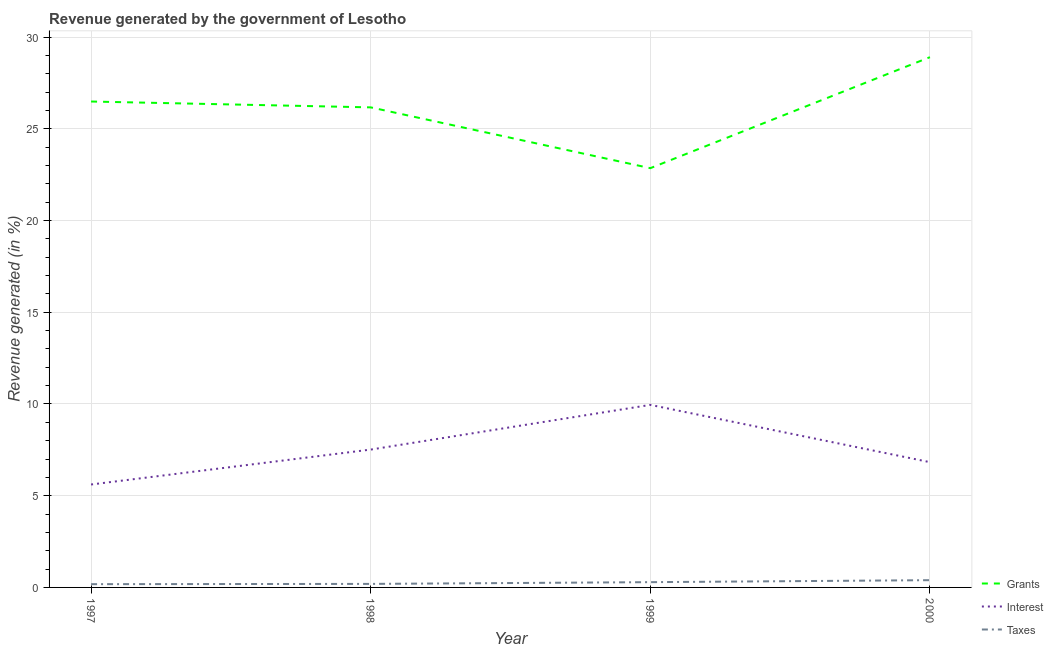How many different coloured lines are there?
Keep it short and to the point. 3. What is the percentage of revenue generated by grants in 1998?
Offer a terse response. 26.17. Across all years, what is the maximum percentage of revenue generated by taxes?
Offer a terse response. 0.4. Across all years, what is the minimum percentage of revenue generated by interest?
Offer a terse response. 5.61. What is the total percentage of revenue generated by taxes in the graph?
Offer a very short reply. 1.05. What is the difference between the percentage of revenue generated by taxes in 1999 and that in 2000?
Your response must be concise. -0.11. What is the difference between the percentage of revenue generated by grants in 1999 and the percentage of revenue generated by taxes in 1998?
Provide a short and direct response. 22.66. What is the average percentage of revenue generated by grants per year?
Keep it short and to the point. 26.1. In the year 2000, what is the difference between the percentage of revenue generated by interest and percentage of revenue generated by taxes?
Make the answer very short. 6.43. In how many years, is the percentage of revenue generated by taxes greater than 2 %?
Your answer should be very brief. 0. What is the ratio of the percentage of revenue generated by grants in 1998 to that in 1999?
Ensure brevity in your answer.  1.15. Is the difference between the percentage of revenue generated by taxes in 1999 and 2000 greater than the difference between the percentage of revenue generated by grants in 1999 and 2000?
Give a very brief answer. Yes. What is the difference between the highest and the second highest percentage of revenue generated by taxes?
Offer a very short reply. 0.11. What is the difference between the highest and the lowest percentage of revenue generated by taxes?
Give a very brief answer. 0.22. Is the percentage of revenue generated by taxes strictly greater than the percentage of revenue generated by interest over the years?
Your answer should be compact. No. How many lines are there?
Your answer should be compact. 3. Are the values on the major ticks of Y-axis written in scientific E-notation?
Your answer should be very brief. No. Does the graph contain any zero values?
Your response must be concise. No. Where does the legend appear in the graph?
Your response must be concise. Bottom right. How many legend labels are there?
Ensure brevity in your answer.  3. How are the legend labels stacked?
Offer a terse response. Vertical. What is the title of the graph?
Offer a terse response. Revenue generated by the government of Lesotho. What is the label or title of the X-axis?
Keep it short and to the point. Year. What is the label or title of the Y-axis?
Make the answer very short. Revenue generated (in %). What is the Revenue generated (in %) in Grants in 1997?
Give a very brief answer. 26.49. What is the Revenue generated (in %) of Interest in 1997?
Make the answer very short. 5.61. What is the Revenue generated (in %) of Taxes in 1997?
Provide a short and direct response. 0.18. What is the Revenue generated (in %) in Grants in 1998?
Offer a terse response. 26.17. What is the Revenue generated (in %) in Interest in 1998?
Your response must be concise. 7.51. What is the Revenue generated (in %) in Taxes in 1998?
Your answer should be compact. 0.19. What is the Revenue generated (in %) in Grants in 1999?
Your response must be concise. 22.86. What is the Revenue generated (in %) in Interest in 1999?
Provide a short and direct response. 9.95. What is the Revenue generated (in %) of Taxes in 1999?
Give a very brief answer. 0.29. What is the Revenue generated (in %) of Grants in 2000?
Give a very brief answer. 28.91. What is the Revenue generated (in %) in Interest in 2000?
Ensure brevity in your answer.  6.83. What is the Revenue generated (in %) of Taxes in 2000?
Give a very brief answer. 0.4. Across all years, what is the maximum Revenue generated (in %) of Grants?
Your response must be concise. 28.91. Across all years, what is the maximum Revenue generated (in %) of Interest?
Your answer should be compact. 9.95. Across all years, what is the maximum Revenue generated (in %) of Taxes?
Keep it short and to the point. 0.4. Across all years, what is the minimum Revenue generated (in %) in Grants?
Keep it short and to the point. 22.86. Across all years, what is the minimum Revenue generated (in %) in Interest?
Your answer should be compact. 5.61. Across all years, what is the minimum Revenue generated (in %) of Taxes?
Your response must be concise. 0.18. What is the total Revenue generated (in %) of Grants in the graph?
Your answer should be compact. 104.42. What is the total Revenue generated (in %) in Interest in the graph?
Your answer should be compact. 29.91. What is the total Revenue generated (in %) in Taxes in the graph?
Ensure brevity in your answer.  1.05. What is the difference between the Revenue generated (in %) of Grants in 1997 and that in 1998?
Keep it short and to the point. 0.32. What is the difference between the Revenue generated (in %) of Interest in 1997 and that in 1998?
Give a very brief answer. -1.9. What is the difference between the Revenue generated (in %) in Taxes in 1997 and that in 1998?
Offer a very short reply. -0.01. What is the difference between the Revenue generated (in %) in Grants in 1997 and that in 1999?
Your response must be concise. 3.63. What is the difference between the Revenue generated (in %) in Interest in 1997 and that in 1999?
Your answer should be very brief. -4.34. What is the difference between the Revenue generated (in %) in Taxes in 1997 and that in 1999?
Your answer should be very brief. -0.11. What is the difference between the Revenue generated (in %) in Grants in 1997 and that in 2000?
Keep it short and to the point. -2.42. What is the difference between the Revenue generated (in %) in Interest in 1997 and that in 2000?
Keep it short and to the point. -1.22. What is the difference between the Revenue generated (in %) in Taxes in 1997 and that in 2000?
Your answer should be compact. -0.22. What is the difference between the Revenue generated (in %) of Grants in 1998 and that in 1999?
Provide a short and direct response. 3.31. What is the difference between the Revenue generated (in %) in Interest in 1998 and that in 1999?
Keep it short and to the point. -2.44. What is the difference between the Revenue generated (in %) in Taxes in 1998 and that in 1999?
Keep it short and to the point. -0.1. What is the difference between the Revenue generated (in %) in Grants in 1998 and that in 2000?
Make the answer very short. -2.74. What is the difference between the Revenue generated (in %) in Interest in 1998 and that in 2000?
Your answer should be compact. 0.69. What is the difference between the Revenue generated (in %) of Taxes in 1998 and that in 2000?
Your answer should be very brief. -0.2. What is the difference between the Revenue generated (in %) of Grants in 1999 and that in 2000?
Keep it short and to the point. -6.05. What is the difference between the Revenue generated (in %) of Interest in 1999 and that in 2000?
Give a very brief answer. 3.12. What is the difference between the Revenue generated (in %) of Taxes in 1999 and that in 2000?
Keep it short and to the point. -0.11. What is the difference between the Revenue generated (in %) of Grants in 1997 and the Revenue generated (in %) of Interest in 1998?
Provide a succinct answer. 18.97. What is the difference between the Revenue generated (in %) of Grants in 1997 and the Revenue generated (in %) of Taxes in 1998?
Your response must be concise. 26.3. What is the difference between the Revenue generated (in %) of Interest in 1997 and the Revenue generated (in %) of Taxes in 1998?
Provide a short and direct response. 5.42. What is the difference between the Revenue generated (in %) in Grants in 1997 and the Revenue generated (in %) in Interest in 1999?
Make the answer very short. 16.54. What is the difference between the Revenue generated (in %) in Grants in 1997 and the Revenue generated (in %) in Taxes in 1999?
Provide a succinct answer. 26.2. What is the difference between the Revenue generated (in %) in Interest in 1997 and the Revenue generated (in %) in Taxes in 1999?
Your answer should be compact. 5.32. What is the difference between the Revenue generated (in %) of Grants in 1997 and the Revenue generated (in %) of Interest in 2000?
Provide a short and direct response. 19.66. What is the difference between the Revenue generated (in %) of Grants in 1997 and the Revenue generated (in %) of Taxes in 2000?
Give a very brief answer. 26.09. What is the difference between the Revenue generated (in %) of Interest in 1997 and the Revenue generated (in %) of Taxes in 2000?
Provide a short and direct response. 5.22. What is the difference between the Revenue generated (in %) of Grants in 1998 and the Revenue generated (in %) of Interest in 1999?
Your answer should be compact. 16.22. What is the difference between the Revenue generated (in %) in Grants in 1998 and the Revenue generated (in %) in Taxes in 1999?
Offer a terse response. 25.88. What is the difference between the Revenue generated (in %) of Interest in 1998 and the Revenue generated (in %) of Taxes in 1999?
Your response must be concise. 7.23. What is the difference between the Revenue generated (in %) of Grants in 1998 and the Revenue generated (in %) of Interest in 2000?
Keep it short and to the point. 19.34. What is the difference between the Revenue generated (in %) in Grants in 1998 and the Revenue generated (in %) in Taxes in 2000?
Provide a short and direct response. 25.77. What is the difference between the Revenue generated (in %) of Interest in 1998 and the Revenue generated (in %) of Taxes in 2000?
Your response must be concise. 7.12. What is the difference between the Revenue generated (in %) of Grants in 1999 and the Revenue generated (in %) of Interest in 2000?
Keep it short and to the point. 16.03. What is the difference between the Revenue generated (in %) of Grants in 1999 and the Revenue generated (in %) of Taxes in 2000?
Keep it short and to the point. 22.46. What is the difference between the Revenue generated (in %) of Interest in 1999 and the Revenue generated (in %) of Taxes in 2000?
Offer a terse response. 9.56. What is the average Revenue generated (in %) of Grants per year?
Offer a very short reply. 26.1. What is the average Revenue generated (in %) of Interest per year?
Offer a terse response. 7.48. What is the average Revenue generated (in %) in Taxes per year?
Provide a succinct answer. 0.26. In the year 1997, what is the difference between the Revenue generated (in %) of Grants and Revenue generated (in %) of Interest?
Your response must be concise. 20.88. In the year 1997, what is the difference between the Revenue generated (in %) in Grants and Revenue generated (in %) in Taxes?
Give a very brief answer. 26.31. In the year 1997, what is the difference between the Revenue generated (in %) in Interest and Revenue generated (in %) in Taxes?
Make the answer very short. 5.43. In the year 1998, what is the difference between the Revenue generated (in %) in Grants and Revenue generated (in %) in Interest?
Ensure brevity in your answer.  18.65. In the year 1998, what is the difference between the Revenue generated (in %) in Grants and Revenue generated (in %) in Taxes?
Your answer should be compact. 25.98. In the year 1998, what is the difference between the Revenue generated (in %) in Interest and Revenue generated (in %) in Taxes?
Offer a terse response. 7.32. In the year 1999, what is the difference between the Revenue generated (in %) of Grants and Revenue generated (in %) of Interest?
Give a very brief answer. 12.9. In the year 1999, what is the difference between the Revenue generated (in %) in Grants and Revenue generated (in %) in Taxes?
Offer a very short reply. 22.57. In the year 1999, what is the difference between the Revenue generated (in %) of Interest and Revenue generated (in %) of Taxes?
Your response must be concise. 9.66. In the year 2000, what is the difference between the Revenue generated (in %) in Grants and Revenue generated (in %) in Interest?
Keep it short and to the point. 22.08. In the year 2000, what is the difference between the Revenue generated (in %) of Grants and Revenue generated (in %) of Taxes?
Make the answer very short. 28.51. In the year 2000, what is the difference between the Revenue generated (in %) in Interest and Revenue generated (in %) in Taxes?
Your response must be concise. 6.43. What is the ratio of the Revenue generated (in %) in Grants in 1997 to that in 1998?
Offer a terse response. 1.01. What is the ratio of the Revenue generated (in %) in Interest in 1997 to that in 1998?
Your answer should be very brief. 0.75. What is the ratio of the Revenue generated (in %) in Taxes in 1997 to that in 1998?
Give a very brief answer. 0.93. What is the ratio of the Revenue generated (in %) in Grants in 1997 to that in 1999?
Provide a succinct answer. 1.16. What is the ratio of the Revenue generated (in %) of Interest in 1997 to that in 1999?
Give a very brief answer. 0.56. What is the ratio of the Revenue generated (in %) of Taxes in 1997 to that in 1999?
Ensure brevity in your answer.  0.62. What is the ratio of the Revenue generated (in %) in Grants in 1997 to that in 2000?
Ensure brevity in your answer.  0.92. What is the ratio of the Revenue generated (in %) of Interest in 1997 to that in 2000?
Offer a very short reply. 0.82. What is the ratio of the Revenue generated (in %) of Taxes in 1997 to that in 2000?
Provide a short and direct response. 0.45. What is the ratio of the Revenue generated (in %) of Grants in 1998 to that in 1999?
Your answer should be compact. 1.15. What is the ratio of the Revenue generated (in %) in Interest in 1998 to that in 1999?
Your response must be concise. 0.76. What is the ratio of the Revenue generated (in %) of Taxes in 1998 to that in 1999?
Offer a terse response. 0.67. What is the ratio of the Revenue generated (in %) in Grants in 1998 to that in 2000?
Your answer should be compact. 0.91. What is the ratio of the Revenue generated (in %) of Interest in 1998 to that in 2000?
Ensure brevity in your answer.  1.1. What is the ratio of the Revenue generated (in %) of Taxes in 1998 to that in 2000?
Your answer should be compact. 0.49. What is the ratio of the Revenue generated (in %) of Grants in 1999 to that in 2000?
Offer a very short reply. 0.79. What is the ratio of the Revenue generated (in %) of Interest in 1999 to that in 2000?
Your answer should be compact. 1.46. What is the ratio of the Revenue generated (in %) of Taxes in 1999 to that in 2000?
Your response must be concise. 0.73. What is the difference between the highest and the second highest Revenue generated (in %) of Grants?
Ensure brevity in your answer.  2.42. What is the difference between the highest and the second highest Revenue generated (in %) of Interest?
Your response must be concise. 2.44. What is the difference between the highest and the second highest Revenue generated (in %) in Taxes?
Offer a terse response. 0.11. What is the difference between the highest and the lowest Revenue generated (in %) in Grants?
Provide a succinct answer. 6.05. What is the difference between the highest and the lowest Revenue generated (in %) of Interest?
Offer a very short reply. 4.34. What is the difference between the highest and the lowest Revenue generated (in %) of Taxes?
Make the answer very short. 0.22. 